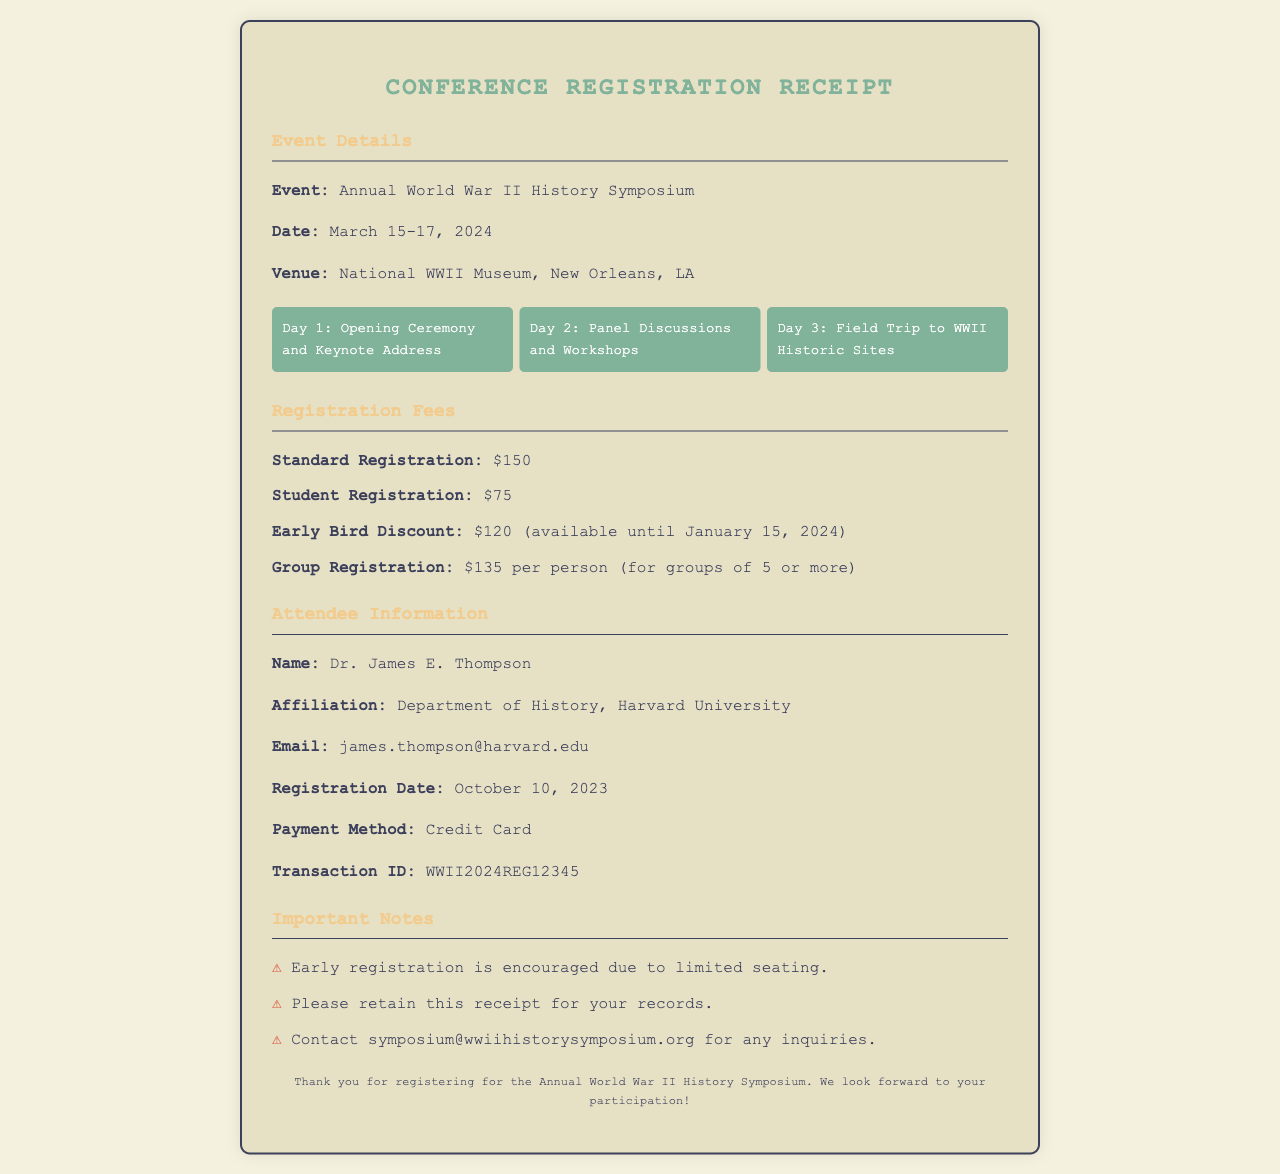What is the event name? The event name is stated clearly in the document as the focus of the event.
Answer: Annual World War II History Symposium When is the registration date? The registration date is mentioned in the attendee information section of the document.
Answer: October 10, 2023 What venue is hosting the symposium? The venue where the event will take place is specified under the event details.
Answer: National WWII Museum, New Orleans, LA How much is the early bird discount fee? The early bird discount fee is listed among other registration fees in the document.
Answer: $120 Who is the attendee's affiliation? The affiliation of the attendee is provided in the attendee information section.
Answer: Department of History, Harvard University How many days will the symposium last? The duration of the symposium is indicated in the event details section.
Answer: Three days What is the group registration fee per person? The group registration fee is detailed in the registration fees section of the document.
Answer: $135 What type of payment was used for registration? The payment method used is indicated in the attendee information.
Answer: Credit Card Is there a contact email for inquiries? The document provides a contact email for inquiries in the important notes section.
Answer: symposium@wwiihistorysymposium.org 